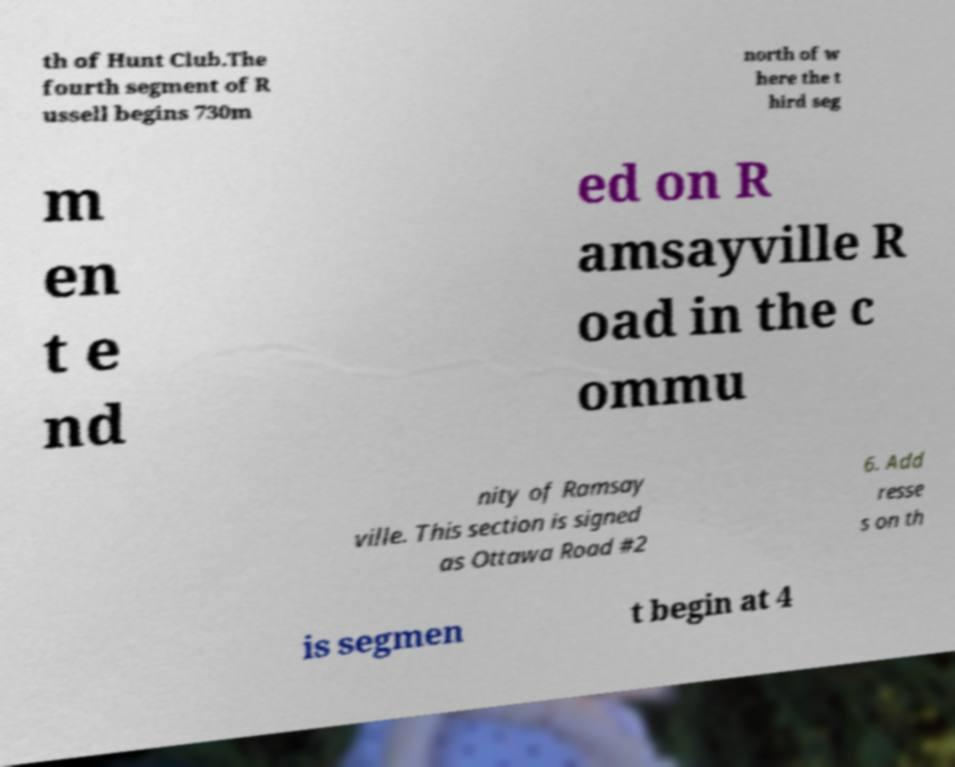Could you extract and type out the text from this image? th of Hunt Club.The fourth segment of R ussell begins 730m north of w here the t hird seg m en t e nd ed on R amsayville R oad in the c ommu nity of Ramsay ville. This section is signed as Ottawa Road #2 6. Add resse s on th is segmen t begin at 4 